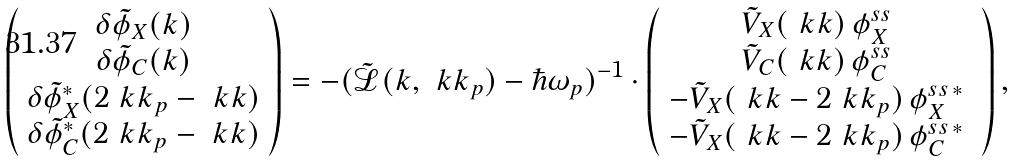Convert formula to latex. <formula><loc_0><loc_0><loc_500><loc_500>\left ( \begin{array} { c } \delta \tilde { \phi } _ { X } ( { k } ) \\ \delta \tilde { \phi } _ { C } ( { k } ) \\ \delta \tilde { \phi } ^ { * } _ { X } ( 2 \ k k _ { p } - \ k k ) \\ \delta \tilde { \phi } ^ { * } _ { C } ( 2 \ k k _ { p } - \ k k ) \end{array} \right ) = - ( \tilde { \mathcal { L } } ( { k } , \ k k _ { p } ) - \hbar { \omega } _ { p } ) ^ { - 1 } \cdot \left ( \begin{array} { c } \tilde { V } _ { X } ( \ k k ) \, \phi _ { X } ^ { s s } \ \\ \tilde { V } _ { C } ( \ k k ) \, \phi _ { C } ^ { s s } \ \\ - \tilde { V } _ { X } ( \ k k - 2 \ k k _ { p } ) \, \phi _ { X } ^ { s s \, * } \ \\ - \tilde { V } _ { X } ( \ k k - 2 \ k k _ { p } ) \, \phi _ { C } ^ { s s \, * } \ \end{array} \right ) ,</formula> 